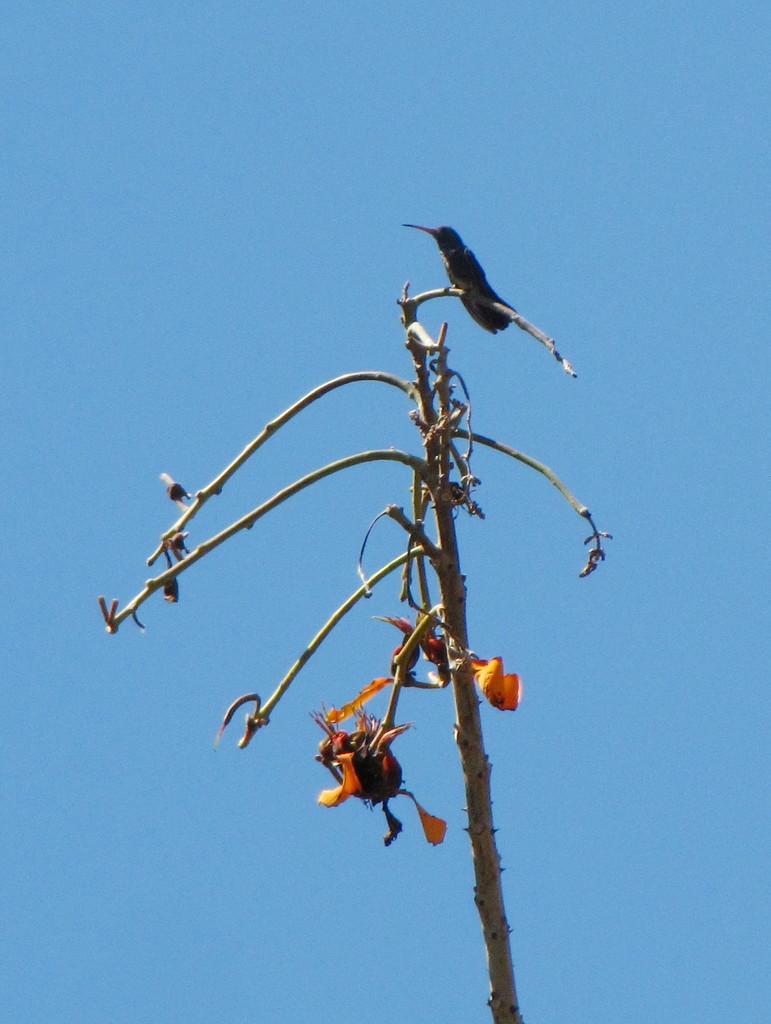Could you give a brief overview of what you see in this image? In this image I can see a bird on the branch. I can see a yellow color flower. Sky is in blue color. 